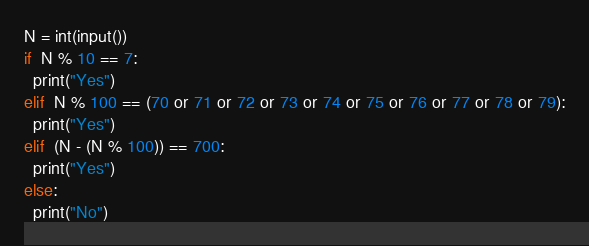<code> <loc_0><loc_0><loc_500><loc_500><_Python_>N = int(input())
if  N % 10 == 7:
  print("Yes") 
elif  N % 100 == (70 or 71 or 72 or 73 or 74 or 75 or 76 or 77 or 78 or 79):
  print("Yes")
elif  (N - (N % 100)) == 700:
  print("Yes")
else:
  print("No")</code> 